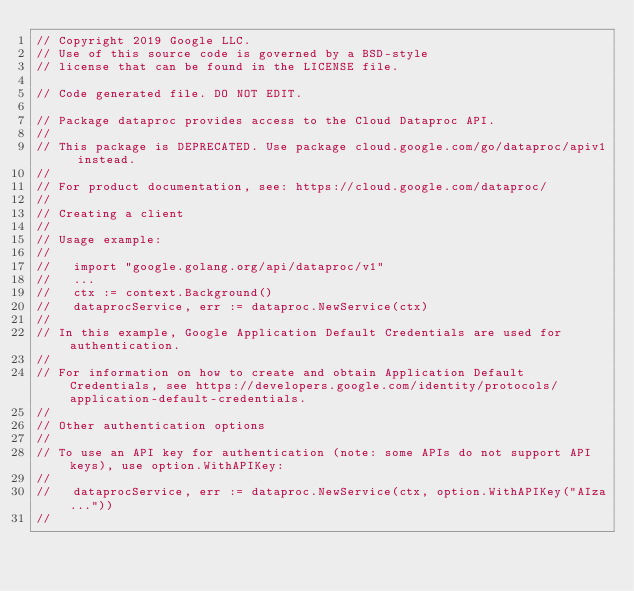Convert code to text. <code><loc_0><loc_0><loc_500><loc_500><_Go_>// Copyright 2019 Google LLC.
// Use of this source code is governed by a BSD-style
// license that can be found in the LICENSE file.

// Code generated file. DO NOT EDIT.

// Package dataproc provides access to the Cloud Dataproc API.
//
// This package is DEPRECATED. Use package cloud.google.com/go/dataproc/apiv1 instead.
//
// For product documentation, see: https://cloud.google.com/dataproc/
//
// Creating a client
//
// Usage example:
//
//   import "google.golang.org/api/dataproc/v1"
//   ...
//   ctx := context.Background()
//   dataprocService, err := dataproc.NewService(ctx)
//
// In this example, Google Application Default Credentials are used for authentication.
//
// For information on how to create and obtain Application Default Credentials, see https://developers.google.com/identity/protocols/application-default-credentials.
//
// Other authentication options
//
// To use an API key for authentication (note: some APIs do not support API keys), use option.WithAPIKey:
//
//   dataprocService, err := dataproc.NewService(ctx, option.WithAPIKey("AIza..."))
//</code> 